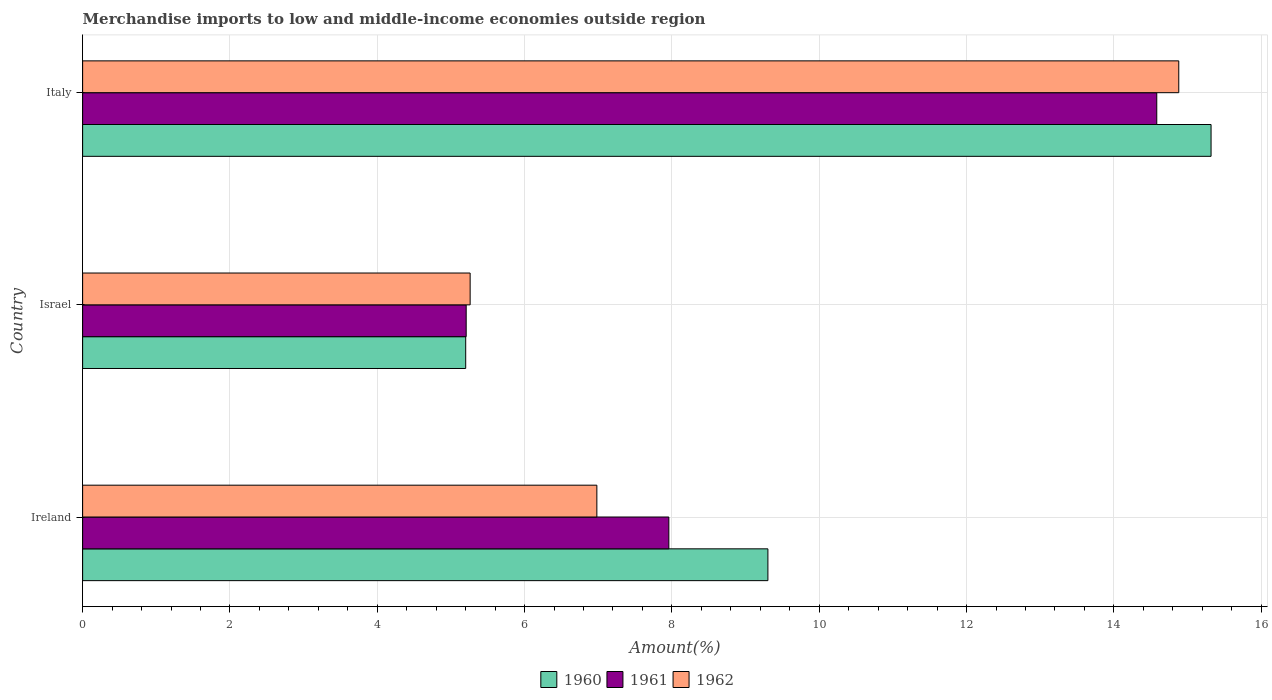How many different coloured bars are there?
Your response must be concise. 3. How many groups of bars are there?
Make the answer very short. 3. Are the number of bars per tick equal to the number of legend labels?
Your response must be concise. Yes. How many bars are there on the 2nd tick from the bottom?
Keep it short and to the point. 3. In how many cases, is the number of bars for a given country not equal to the number of legend labels?
Your response must be concise. 0. What is the percentage of amount earned from merchandise imports in 1961 in Israel?
Offer a terse response. 5.21. Across all countries, what is the maximum percentage of amount earned from merchandise imports in 1961?
Offer a very short reply. 14.58. Across all countries, what is the minimum percentage of amount earned from merchandise imports in 1960?
Offer a terse response. 5.2. In which country was the percentage of amount earned from merchandise imports in 1962 maximum?
Provide a succinct answer. Italy. In which country was the percentage of amount earned from merchandise imports in 1961 minimum?
Give a very brief answer. Israel. What is the total percentage of amount earned from merchandise imports in 1960 in the graph?
Give a very brief answer. 29.82. What is the difference between the percentage of amount earned from merchandise imports in 1961 in Ireland and that in Italy?
Offer a very short reply. -6.62. What is the difference between the percentage of amount earned from merchandise imports in 1962 in Italy and the percentage of amount earned from merchandise imports in 1961 in Ireland?
Give a very brief answer. 6.92. What is the average percentage of amount earned from merchandise imports in 1962 per country?
Keep it short and to the point. 9.04. What is the difference between the percentage of amount earned from merchandise imports in 1962 and percentage of amount earned from merchandise imports in 1961 in Israel?
Your answer should be compact. 0.05. In how many countries, is the percentage of amount earned from merchandise imports in 1962 greater than 5.2 %?
Ensure brevity in your answer.  3. What is the ratio of the percentage of amount earned from merchandise imports in 1962 in Ireland to that in Israel?
Provide a succinct answer. 1.33. Is the percentage of amount earned from merchandise imports in 1960 in Ireland less than that in Italy?
Your answer should be very brief. Yes. Is the difference between the percentage of amount earned from merchandise imports in 1962 in Israel and Italy greater than the difference between the percentage of amount earned from merchandise imports in 1961 in Israel and Italy?
Provide a short and direct response. No. What is the difference between the highest and the second highest percentage of amount earned from merchandise imports in 1962?
Provide a succinct answer. 7.9. What is the difference between the highest and the lowest percentage of amount earned from merchandise imports in 1962?
Keep it short and to the point. 9.62. In how many countries, is the percentage of amount earned from merchandise imports in 1962 greater than the average percentage of amount earned from merchandise imports in 1962 taken over all countries?
Your answer should be very brief. 1. What does the 2nd bar from the top in Ireland represents?
Offer a terse response. 1961. What does the 3rd bar from the bottom in Ireland represents?
Your answer should be very brief. 1962. Is it the case that in every country, the sum of the percentage of amount earned from merchandise imports in 1962 and percentage of amount earned from merchandise imports in 1960 is greater than the percentage of amount earned from merchandise imports in 1961?
Offer a terse response. Yes. How many countries are there in the graph?
Give a very brief answer. 3. Are the values on the major ticks of X-axis written in scientific E-notation?
Your answer should be very brief. No. How many legend labels are there?
Make the answer very short. 3. How are the legend labels stacked?
Provide a succinct answer. Horizontal. What is the title of the graph?
Offer a terse response. Merchandise imports to low and middle-income economies outside region. What is the label or title of the X-axis?
Your answer should be compact. Amount(%). What is the label or title of the Y-axis?
Your answer should be very brief. Country. What is the Amount(%) in 1960 in Ireland?
Give a very brief answer. 9.3. What is the Amount(%) of 1961 in Ireland?
Keep it short and to the point. 7.96. What is the Amount(%) of 1962 in Ireland?
Give a very brief answer. 6.98. What is the Amount(%) of 1960 in Israel?
Make the answer very short. 5.2. What is the Amount(%) of 1961 in Israel?
Give a very brief answer. 5.21. What is the Amount(%) in 1962 in Israel?
Your response must be concise. 5.26. What is the Amount(%) in 1960 in Italy?
Your answer should be very brief. 15.32. What is the Amount(%) of 1961 in Italy?
Offer a terse response. 14.58. What is the Amount(%) in 1962 in Italy?
Give a very brief answer. 14.88. Across all countries, what is the maximum Amount(%) of 1960?
Your answer should be very brief. 15.32. Across all countries, what is the maximum Amount(%) of 1961?
Your answer should be very brief. 14.58. Across all countries, what is the maximum Amount(%) in 1962?
Offer a terse response. 14.88. Across all countries, what is the minimum Amount(%) of 1960?
Your answer should be very brief. 5.2. Across all countries, what is the minimum Amount(%) in 1961?
Provide a short and direct response. 5.21. Across all countries, what is the minimum Amount(%) of 1962?
Ensure brevity in your answer.  5.26. What is the total Amount(%) in 1960 in the graph?
Your response must be concise. 29.82. What is the total Amount(%) in 1961 in the graph?
Your response must be concise. 27.75. What is the total Amount(%) in 1962 in the graph?
Provide a succinct answer. 27.12. What is the difference between the Amount(%) of 1960 in Ireland and that in Israel?
Keep it short and to the point. 4.1. What is the difference between the Amount(%) of 1961 in Ireland and that in Israel?
Provide a short and direct response. 2.75. What is the difference between the Amount(%) in 1962 in Ireland and that in Israel?
Your answer should be compact. 1.72. What is the difference between the Amount(%) in 1960 in Ireland and that in Italy?
Offer a terse response. -6.02. What is the difference between the Amount(%) in 1961 in Ireland and that in Italy?
Offer a very short reply. -6.62. What is the difference between the Amount(%) of 1962 in Ireland and that in Italy?
Provide a succinct answer. -7.9. What is the difference between the Amount(%) in 1960 in Israel and that in Italy?
Your answer should be very brief. -10.12. What is the difference between the Amount(%) of 1961 in Israel and that in Italy?
Offer a terse response. -9.38. What is the difference between the Amount(%) of 1962 in Israel and that in Italy?
Your response must be concise. -9.62. What is the difference between the Amount(%) in 1960 in Ireland and the Amount(%) in 1961 in Israel?
Your answer should be compact. 4.1. What is the difference between the Amount(%) of 1960 in Ireland and the Amount(%) of 1962 in Israel?
Offer a very short reply. 4.04. What is the difference between the Amount(%) of 1961 in Ireland and the Amount(%) of 1962 in Israel?
Offer a terse response. 2.7. What is the difference between the Amount(%) of 1960 in Ireland and the Amount(%) of 1961 in Italy?
Offer a terse response. -5.28. What is the difference between the Amount(%) of 1960 in Ireland and the Amount(%) of 1962 in Italy?
Provide a short and direct response. -5.58. What is the difference between the Amount(%) of 1961 in Ireland and the Amount(%) of 1962 in Italy?
Give a very brief answer. -6.92. What is the difference between the Amount(%) of 1960 in Israel and the Amount(%) of 1961 in Italy?
Your answer should be compact. -9.38. What is the difference between the Amount(%) of 1960 in Israel and the Amount(%) of 1962 in Italy?
Make the answer very short. -9.68. What is the difference between the Amount(%) of 1961 in Israel and the Amount(%) of 1962 in Italy?
Your answer should be very brief. -9.67. What is the average Amount(%) in 1960 per country?
Keep it short and to the point. 9.94. What is the average Amount(%) of 1961 per country?
Keep it short and to the point. 9.25. What is the average Amount(%) in 1962 per country?
Give a very brief answer. 9.04. What is the difference between the Amount(%) of 1960 and Amount(%) of 1961 in Ireland?
Offer a very short reply. 1.34. What is the difference between the Amount(%) of 1960 and Amount(%) of 1962 in Ireland?
Provide a succinct answer. 2.32. What is the difference between the Amount(%) of 1961 and Amount(%) of 1962 in Ireland?
Make the answer very short. 0.98. What is the difference between the Amount(%) of 1960 and Amount(%) of 1961 in Israel?
Your answer should be very brief. -0.01. What is the difference between the Amount(%) of 1960 and Amount(%) of 1962 in Israel?
Offer a terse response. -0.06. What is the difference between the Amount(%) of 1961 and Amount(%) of 1962 in Israel?
Keep it short and to the point. -0.05. What is the difference between the Amount(%) in 1960 and Amount(%) in 1961 in Italy?
Ensure brevity in your answer.  0.74. What is the difference between the Amount(%) of 1960 and Amount(%) of 1962 in Italy?
Provide a succinct answer. 0.44. What is the difference between the Amount(%) in 1961 and Amount(%) in 1962 in Italy?
Your answer should be compact. -0.3. What is the ratio of the Amount(%) in 1960 in Ireland to that in Israel?
Your answer should be compact. 1.79. What is the ratio of the Amount(%) in 1961 in Ireland to that in Israel?
Your response must be concise. 1.53. What is the ratio of the Amount(%) in 1962 in Ireland to that in Israel?
Your response must be concise. 1.33. What is the ratio of the Amount(%) of 1960 in Ireland to that in Italy?
Offer a very short reply. 0.61. What is the ratio of the Amount(%) of 1961 in Ireland to that in Italy?
Your response must be concise. 0.55. What is the ratio of the Amount(%) in 1962 in Ireland to that in Italy?
Offer a very short reply. 0.47. What is the ratio of the Amount(%) in 1960 in Israel to that in Italy?
Your answer should be very brief. 0.34. What is the ratio of the Amount(%) in 1961 in Israel to that in Italy?
Your answer should be very brief. 0.36. What is the ratio of the Amount(%) of 1962 in Israel to that in Italy?
Make the answer very short. 0.35. What is the difference between the highest and the second highest Amount(%) in 1960?
Your answer should be very brief. 6.02. What is the difference between the highest and the second highest Amount(%) of 1961?
Provide a short and direct response. 6.62. What is the difference between the highest and the second highest Amount(%) of 1962?
Your response must be concise. 7.9. What is the difference between the highest and the lowest Amount(%) in 1960?
Keep it short and to the point. 10.12. What is the difference between the highest and the lowest Amount(%) of 1961?
Keep it short and to the point. 9.38. What is the difference between the highest and the lowest Amount(%) of 1962?
Your answer should be very brief. 9.62. 